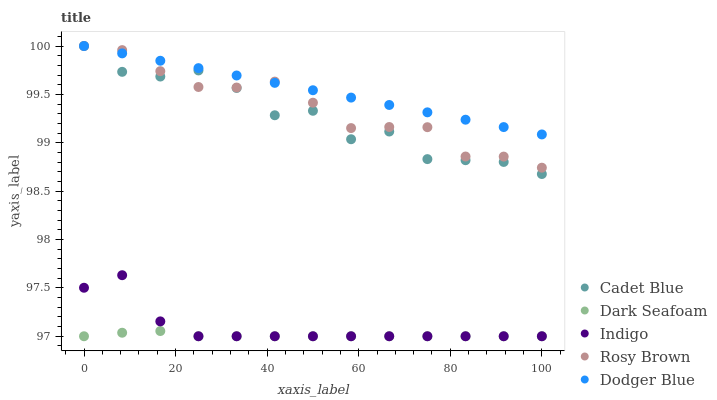Does Dark Seafoam have the minimum area under the curve?
Answer yes or no. Yes. Does Dodger Blue have the maximum area under the curve?
Answer yes or no. Yes. Does Cadet Blue have the minimum area under the curve?
Answer yes or no. No. Does Cadet Blue have the maximum area under the curve?
Answer yes or no. No. Is Dodger Blue the smoothest?
Answer yes or no. Yes. Is Cadet Blue the roughest?
Answer yes or no. Yes. Is Dark Seafoam the smoothest?
Answer yes or no. No. Is Dark Seafoam the roughest?
Answer yes or no. No. Does Dark Seafoam have the lowest value?
Answer yes or no. Yes. Does Cadet Blue have the lowest value?
Answer yes or no. No. Does Rosy Brown have the highest value?
Answer yes or no. Yes. Does Dark Seafoam have the highest value?
Answer yes or no. No. Is Dark Seafoam less than Cadet Blue?
Answer yes or no. Yes. Is Cadet Blue greater than Indigo?
Answer yes or no. Yes. Does Cadet Blue intersect Dodger Blue?
Answer yes or no. Yes. Is Cadet Blue less than Dodger Blue?
Answer yes or no. No. Is Cadet Blue greater than Dodger Blue?
Answer yes or no. No. Does Dark Seafoam intersect Cadet Blue?
Answer yes or no. No. 